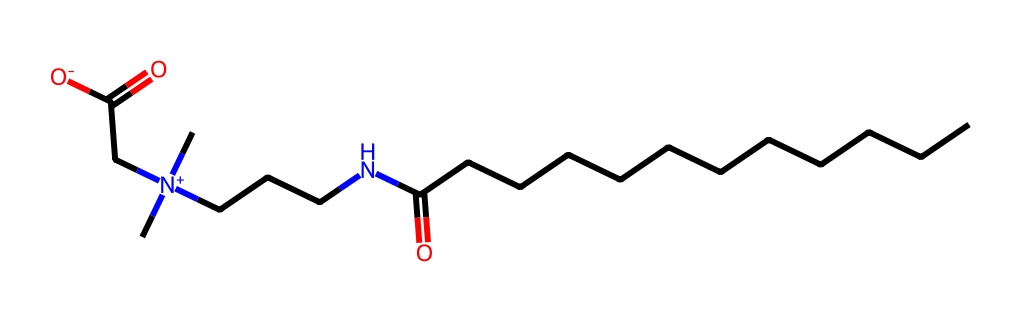how many carbon atoms are in cocamidopropyl betaine? The SMILES notation indicates the presence of 13 carbon atoms (there are long carbon chains represented as C's and those attached to nitrogen as N-CCC).
Answer: 13 what functional groups are present in cocamidopropyl betaine? The chemical structure shows both a carboxylic acid (–COOH) and a quaternary ammonium group, indicating a positive charge on the nitrogen atoms.
Answer: carboxylic acid, quaternary ammonium what is the charge of the nitrogen atom in cocamidopropyl betaine? The nitrogen atom in the quaternary ammonium group is bonded to four carbon chains, which gives it a positive charge (+).
Answer: positive which part of the molecule provides emulsifying properties? The long non-polar hydrocarbon chain interacts with oils, while the polar quaternary ammonium part interacts with water, giving it surfactant properties.
Answer: non-polar hydrocarbon chain and polar ammonium how many nitrogen atoms are present in cocamidopropyl betaine? The SMILES representation shows 2 nitrogen atoms in total: one within the quaternary ammonium group and one part of the amide bond.
Answer: 2 what type of surfactant is cocamidopropyl betaine classified as? It is commonly classified as an amphoteric surfactant due to its ability to act as both a cation and anion depending on pH conditions.
Answer: amphoteric 